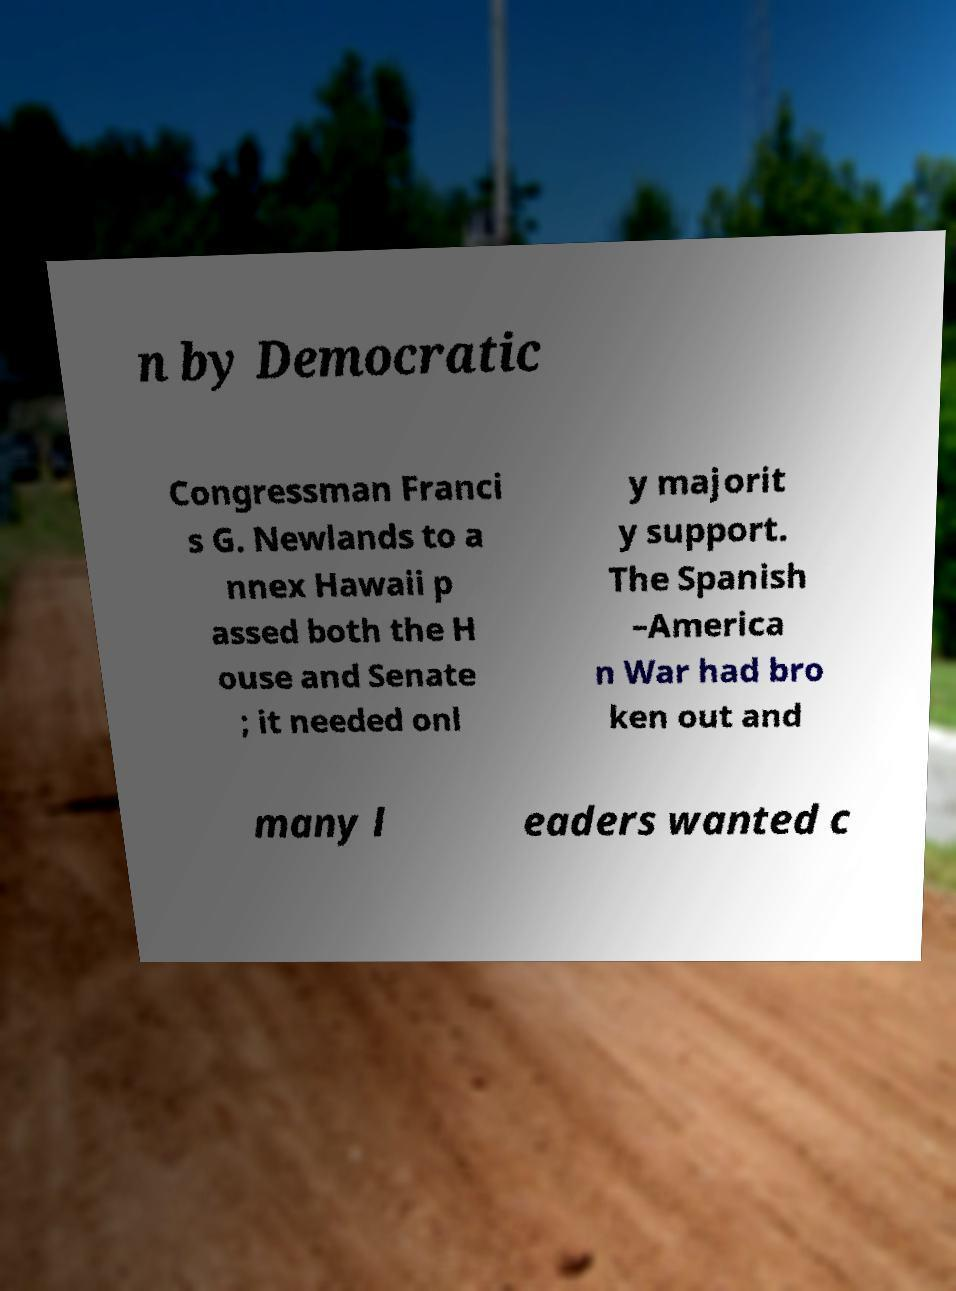What messages or text are displayed in this image? I need them in a readable, typed format. n by Democratic Congressman Franci s G. Newlands to a nnex Hawaii p assed both the H ouse and Senate ; it needed onl y majorit y support. The Spanish –America n War had bro ken out and many l eaders wanted c 